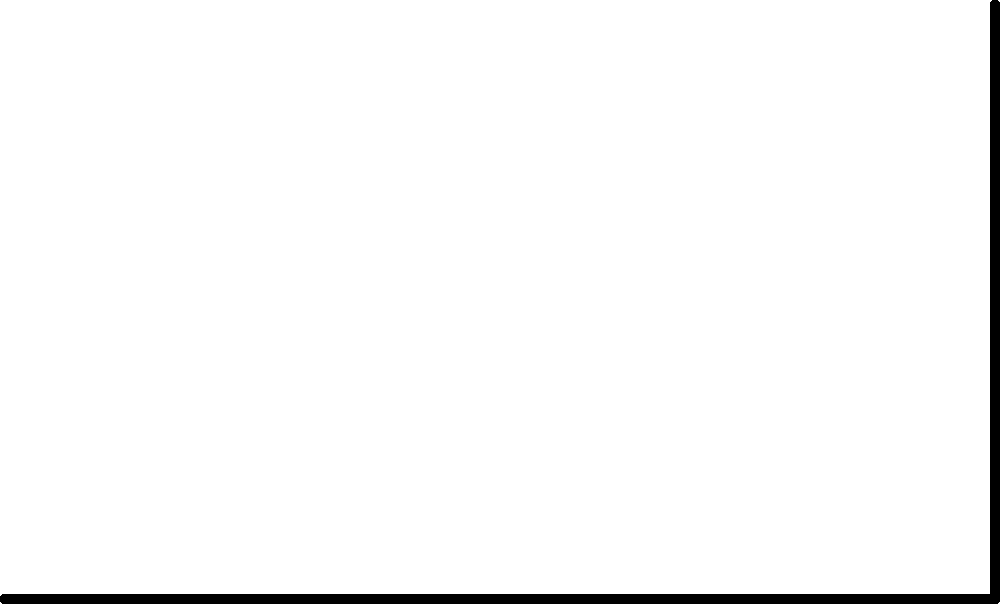A business owner performs bicep curls as part of their fitness routine. The diagram shows a simplified model of the arm during a bicep curl. The forearm length is 30 cm, and the weight held is 10 kg. If the angle between the forearm and upper arm ($\theta$) is 60°, calculate the torque generated by the bicep muscle at the elbow joint. Assume the muscle force ($F_m$) acts perpendicular to the forearm, and ignore the weight of the forearm itself. To solve this problem, we'll follow these steps:

1. Identify the given information:
   - Forearm length = 30 cm = 0.3 m
   - Weight = 10 kg
   - Angle $\theta$ = 60°

2. Calculate the weight force ($F_w$):
   $F_w = m \cdot g = 10 \text{ kg} \cdot 9.8 \text{ m/s}^2 = 98 \text{ N}$

3. Calculate the moment arm for the weight force:
   $r_w = 0.3 \text{ m} \cdot \cos(60°) = 0.3 \text{ m} \cdot 0.5 = 0.15 \text{ m}$

4. Calculate the torque due to the weight:
   $\tau_w = F_w \cdot r_w = 98 \text{ N} \cdot 0.15 \text{ m} = 14.7 \text{ N·m}$

5. For equilibrium, the torque generated by the bicep muscle must equal the torque due to the weight:
   $\tau_m = \tau_w = 14.7 \text{ N·m}$

6. The torque generated by the bicep muscle is the product of the muscle force ($F_m$) and the entire forearm length (as it acts perpendicularly):
   $\tau_m = F_m \cdot 0.3 \text{ m} = 14.7 \text{ N·m}$

7. Calculate the required muscle force:
   $F_m = 14.7 \text{ N·m} / 0.3 \text{ m} = 49 \text{ N}$

Therefore, the torque generated by the bicep muscle at the elbow joint is 14.7 N·m.
Answer: 14.7 N·m 